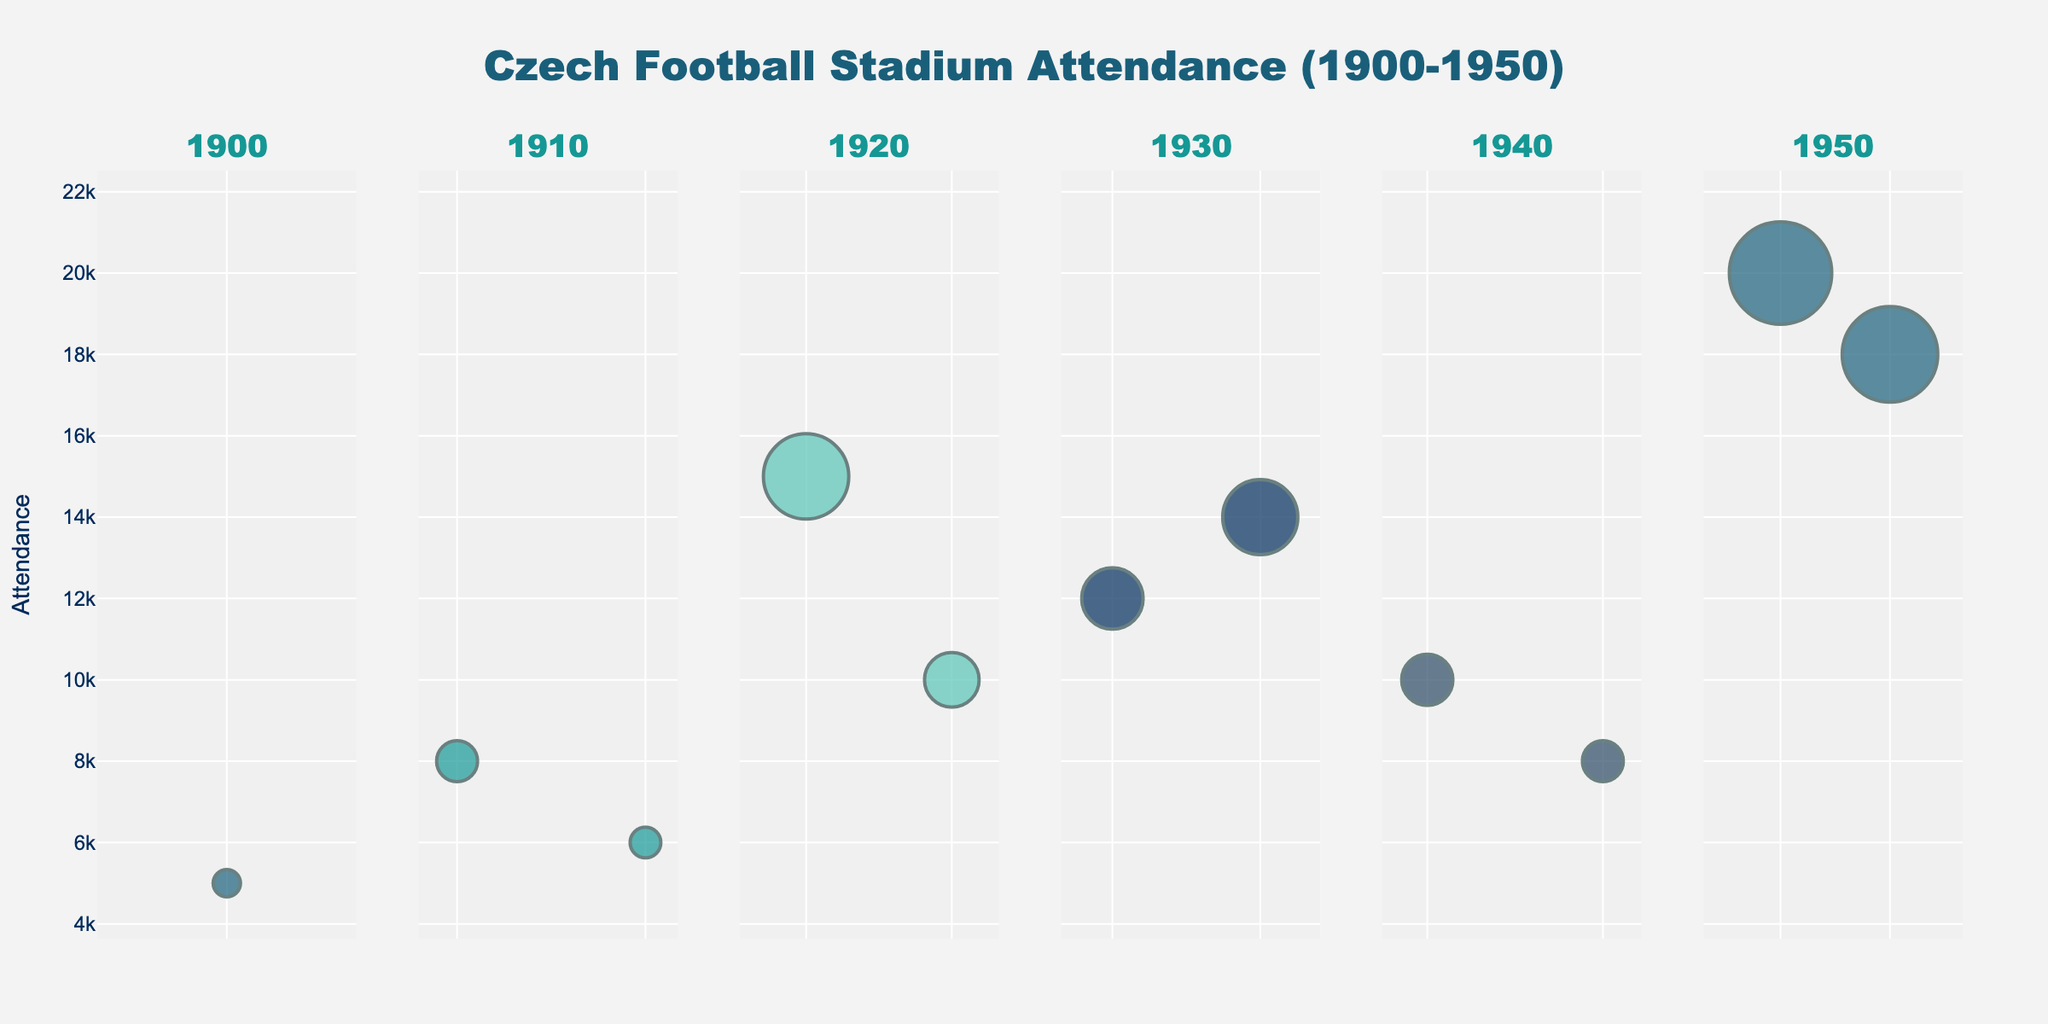What's the title of the chart? The title of the chart is written at the top and can be read directly from the figure.
Answer: Czech Football Stadium Attendance (1900-1950) Which year had the highest attendance? By observing the highest bubble on the y-axis across all subplots, 1950 has the highest attendance with Stadion Evžena Rošického showing 20,000.
Answer: 1950 How many stadiums are represented in the year 1920? Each bubble in the 1920 subplot represents a stadium. Count the number of bubbles in the 1920 subplot.
Answer: 2 What's the average capacity of the stadiums in 1930? The capacities in 1930 for Na Julisce (18,000) and Rosický Stadium (22,000) can be added together and divided by 2. (18,000 + 22,000) / 2 = 20,000
Answer: 20,000 Which year has the smallest bubbles overall? Smaller bubbles correspond to lower capacities; compare each subplot's bubbles. 1900 has the smallest bubbles overall.
Answer: 1900 Which stadium had the highest attendance in 1910? In the 1910 subplot, the highest bubble on the y-axis corresponds to Sparta Stadium with 8,000 attendees.
Answer: Sparta Stadium Between 1930 and 1940, did the average capacity of stadiums increase or decrease? Calculate the average capacity for each year (1930: (18,000 + 22,000) / 2 = 20,000 and 1940: (15,000 + 12,000) / 2 = 13,500) and compare them. It decreased from 20,000 to 13,500.
Answer: Decrease What is the difference in attendance between Letná Stadium in 1900 and Bazaly in 1940? Subtract attendance of Letná Stadium in 1900 (5,000) from Bazaly in 1940 (8,000). 8,000 - 5,000 = 3,000
Answer: 3,000 Which stadium had the highest capacity throughout the entire period? Compare the sizes of the largest bubbles across all subplots; Stadion Evžena Rošického in 1950 with 30,000 capacity has the largest bubble.
Answer: Stadion Evžena Rošického By how much did the attendance at Eden Arena in 1920 exceed the attendance at Na Julisce in 1930? Compare the attendance figures from Eden Arena in 1920 (10,000) and Na Julisce in 1930 (12,000). The attendance at Eden Arena did not exceed that of Na Julisce; it's less by 2,000.
Answer: -2,000 